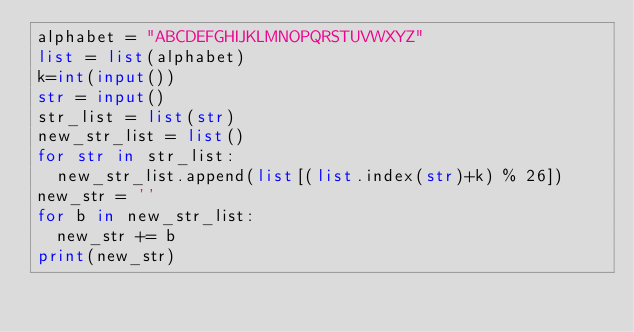<code> <loc_0><loc_0><loc_500><loc_500><_Python_>alphabet = "ABCDEFGHIJKLMNOPQRSTUVWXYZ"
list = list(alphabet)
k=int(input())
str = input()
str_list = list(str)
new_str_list = list()
for str in str_list:
  new_str_list.append(list[(list.index(str)+k) % 26])
new_str = ''
for b in new_str_list:
  new_str += b
print(new_str)</code> 